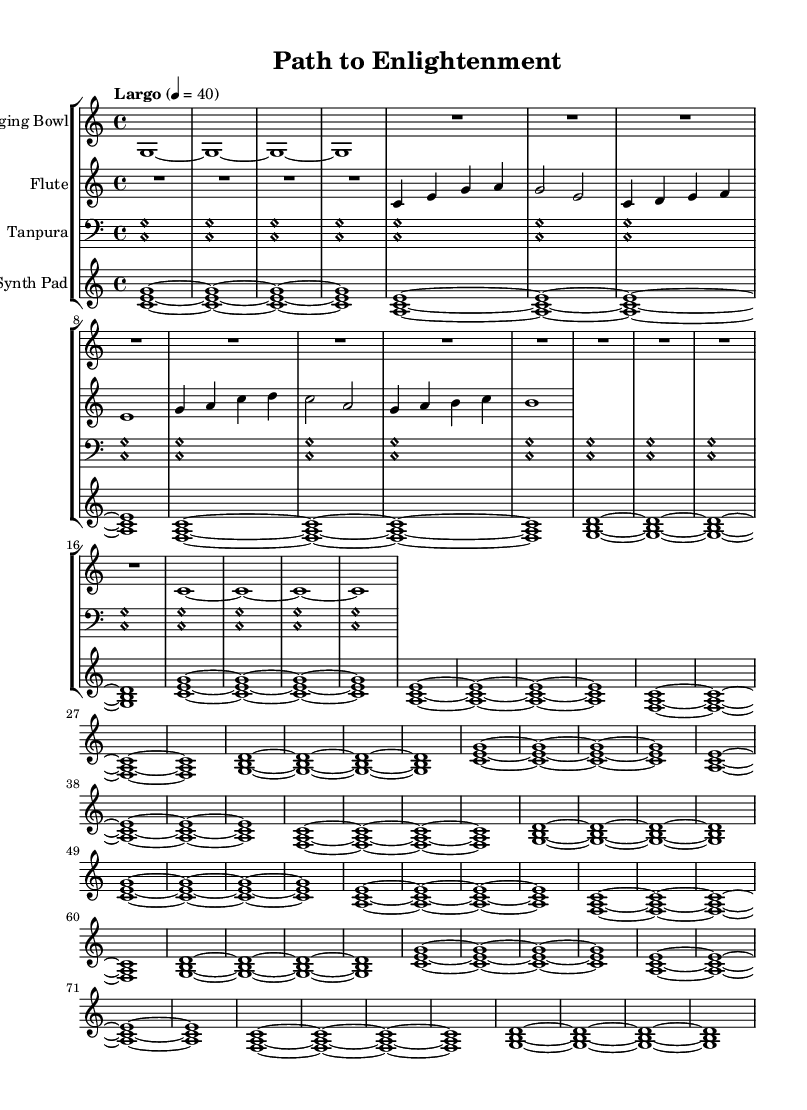What is the key signature of this music? The key signature is C major, which has no sharps or flats.
Answer: C major What is the time signature? The time signature is indicated at the beginning of the score; it shows that there are four beats in a measure.
Answer: 4/4 What is the tempo marking of this piece? The tempo marking is specified as "Largo," which indicates a slow pace.
Answer: Largo How many measures does the singing bowl part have? By counting the number of distinct measures in the singing bowl staff, you can find that it contains a series of sixteen quarter notes and rests, totaling 16 measures.
Answer: 16 What instruments are involved in this composition? The instruments are listed at the beginning of each staff and include Singing Bowl, Flute, Tanpura, and Synth Pad.
Answer: Singing Bowl, Flute, Tanpura, Synth Pad What chords are primarily used in the synth pad section? The synth pad section features repeated harmonic structures made up of triads, indicating the use of the chords C, A minor, F, and G major.
Answer: C, A minor, F, G Which instrument is likely to provide the drone effect in this composition? The tanpura, being tuned to create a continuous sound that others can resonate with, serves the traditional role of providing a drone.
Answer: Tanpura 